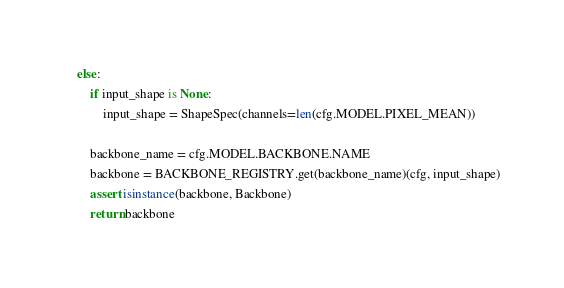Convert code to text. <code><loc_0><loc_0><loc_500><loc_500><_Python_>
    else:
        if input_shape is None:
            input_shape = ShapeSpec(channels=len(cfg.MODEL.PIXEL_MEAN))

        backbone_name = cfg.MODEL.BACKBONE.NAME
        backbone = BACKBONE_REGISTRY.get(backbone_name)(cfg, input_shape)
        assert isinstance(backbone, Backbone)
        return backbone
</code> 